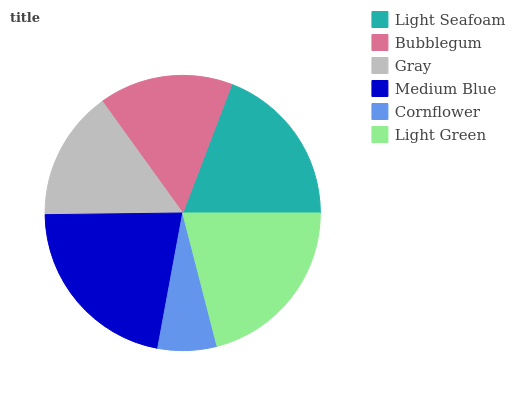Is Cornflower the minimum?
Answer yes or no. Yes. Is Medium Blue the maximum?
Answer yes or no. Yes. Is Bubblegum the minimum?
Answer yes or no. No. Is Bubblegum the maximum?
Answer yes or no. No. Is Light Seafoam greater than Bubblegum?
Answer yes or no. Yes. Is Bubblegum less than Light Seafoam?
Answer yes or no. Yes. Is Bubblegum greater than Light Seafoam?
Answer yes or no. No. Is Light Seafoam less than Bubblegum?
Answer yes or no. No. Is Light Seafoam the high median?
Answer yes or no. Yes. Is Bubblegum the low median?
Answer yes or no. Yes. Is Bubblegum the high median?
Answer yes or no. No. Is Cornflower the low median?
Answer yes or no. No. 